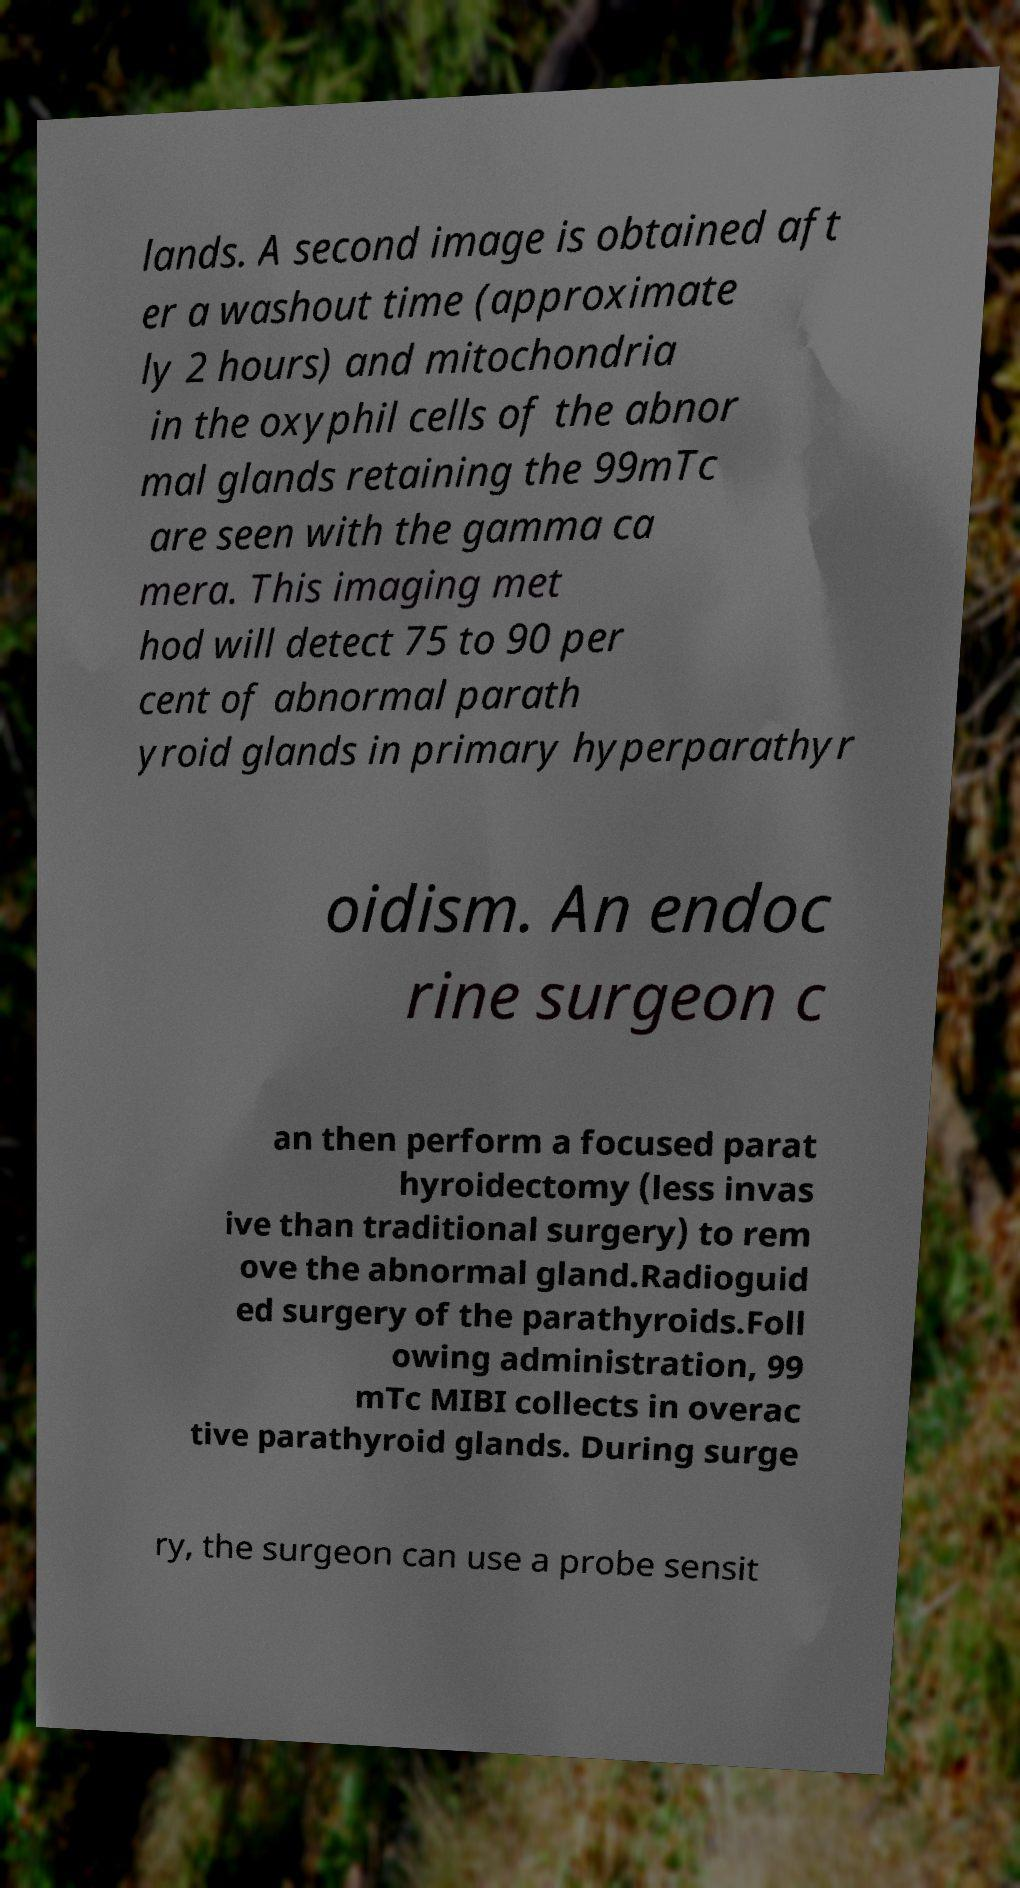Could you assist in decoding the text presented in this image and type it out clearly? lands. A second image is obtained aft er a washout time (approximate ly 2 hours) and mitochondria in the oxyphil cells of the abnor mal glands retaining the 99mTc are seen with the gamma ca mera. This imaging met hod will detect 75 to 90 per cent of abnormal parath yroid glands in primary hyperparathyr oidism. An endoc rine surgeon c an then perform a focused parat hyroidectomy (less invas ive than traditional surgery) to rem ove the abnormal gland.Radioguid ed surgery of the parathyroids.Foll owing administration, 99 mTc MIBI collects in overac tive parathyroid glands. During surge ry, the surgeon can use a probe sensit 